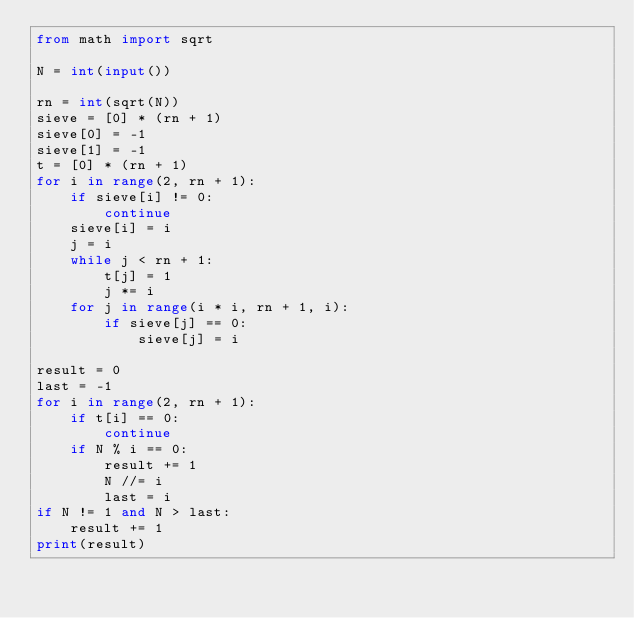<code> <loc_0><loc_0><loc_500><loc_500><_Python_>from math import sqrt

N = int(input())

rn = int(sqrt(N))
sieve = [0] * (rn + 1)
sieve[0] = -1
sieve[1] = -1
t = [0] * (rn + 1)
for i in range(2, rn + 1):
    if sieve[i] != 0:
        continue
    sieve[i] = i
    j = i
    while j < rn + 1:
        t[j] = 1
        j *= i
    for j in range(i * i, rn + 1, i):
        if sieve[j] == 0:
            sieve[j] = i

result = 0
last = -1
for i in range(2, rn + 1):
    if t[i] == 0:
        continue
    if N % i == 0:
        result += 1
        N //= i
        last = i
if N != 1 and N > last:
    result += 1
print(result)
</code> 